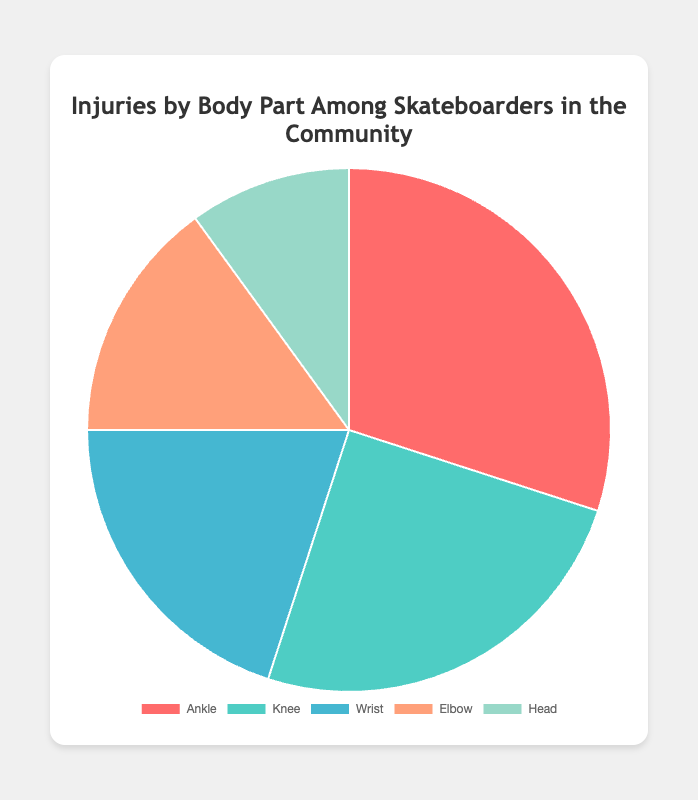Which body part has the highest percentage of injuries among skateboarders in the community? By looking at the pie chart, it's clear that the segment with the highest percentage is labeled "Ankle", representing 30% of injuries.
Answer: Ankle Which body part has the lowest percentage of injuries among skateboarders in the community? The pie chart's smallest segment is the one for "Head", which shows a 10% injury rate.
Answer: Head How many percentage points higher are ankle injuries compared to knee injuries? Ankle injuries are 30% while knee injuries are 25%. The difference is 30% - 25% = 5%.
Answer: 5 Which body parts together make up half of the injuries? Adding the percentages, "Ankle" has 30% and "Knee" has 25%. Together, 30% + 25% = 55%, which is more than half, so only one will need more. Then check the next significant addition: Wrist (20%),  Ankle (30%) + Knee (25%) + Wrist (20%) = 75%. Hence Ankle and Knee alone is 50.
Answer: Ankle and Knee What is the combined percentage of injuries for wrist and elbow? From the chart, the wrist accounts for 20% and the elbow accounts for 15%. Adding these together, 20% + 15% = 35%.
Answer: 35 Are there more injuries to the head or the elbow among skateboarders? The pie chart shows head injuries at 10% and elbow injuries at 15%. Since 15% > 10%, there are more elbow injuries.
Answer: Elbow What color represents the wrist injuries in the pie chart? By checking the color code assigned to the wrist section of the pie chart, wrist injuries are represented by the 4th color in the plank setup, along with descriptions like #FFA07A (orange-like peach).
Answer: Peach How many percentage points do ankle injuries exceed wrist injuries? Ankle injuries are 30% and wrist injuries are 20%. Therefore, 30% - 20% = 10%.
Answer: 10 Which injury categories combined make up less than 35% of injuries? From the pie chart, head injuries are 10% and elbow injuries are 15%. Adding these together, 10% + 15% = 25%, which is less than 35%. These are the only accumulative sub-categories accomplishable.
Answer: Head and Elbow What is the difference in percentage points between the most and least injured body parts? The most injured body part is the ankle at 30% and the least injured body part is the head at 10%. Hence, 30% - 10% = 20%.
Answer: 20 